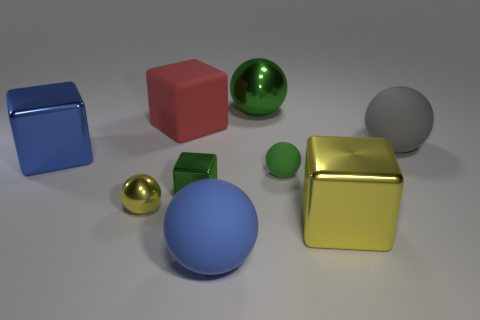Subtract all large green shiny balls. How many balls are left? 4 Subtract all blue balls. How many balls are left? 4 Add 1 big balls. How many objects exist? 10 Subtract 4 cubes. How many cubes are left? 0 Subtract all large gray rubber balls. Subtract all yellow spheres. How many objects are left? 7 Add 4 gray matte objects. How many gray matte objects are left? 5 Add 5 small blue matte things. How many small blue matte things exist? 5 Subtract 1 yellow blocks. How many objects are left? 8 Subtract all balls. How many objects are left? 4 Subtract all brown blocks. Subtract all gray spheres. How many blocks are left? 4 